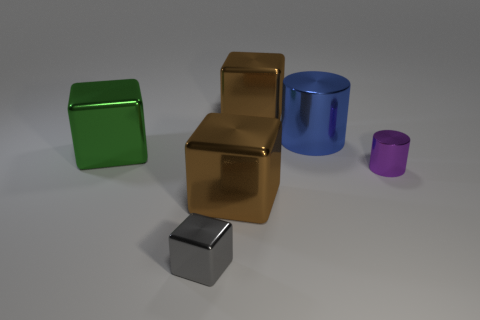Is the small shiny cylinder the same color as the large cylinder?
Offer a very short reply. No. The small metal thing in front of the large shiny thing in front of the green metallic block is what shape?
Your response must be concise. Cube. There is a green thing that is the same material as the gray thing; what shape is it?
Ensure brevity in your answer.  Cube. What number of other objects are the same shape as the blue object?
Ensure brevity in your answer.  1. Is the size of the metal cube that is left of the gray shiny object the same as the gray metal cube?
Your response must be concise. No. Is the number of green cubes that are left of the big green object greater than the number of large metallic things?
Your response must be concise. No. There is a brown object behind the large blue thing; what number of large brown metal things are in front of it?
Provide a short and direct response. 1. Is the number of small purple metallic things behind the small purple metallic cylinder less than the number of big blue objects?
Provide a short and direct response. Yes. There is a small shiny object to the left of the brown shiny thing that is in front of the small purple metallic cylinder; is there a shiny object that is behind it?
Provide a short and direct response. Yes. Is the material of the green block the same as the small thing that is to the left of the blue object?
Make the answer very short. Yes. 